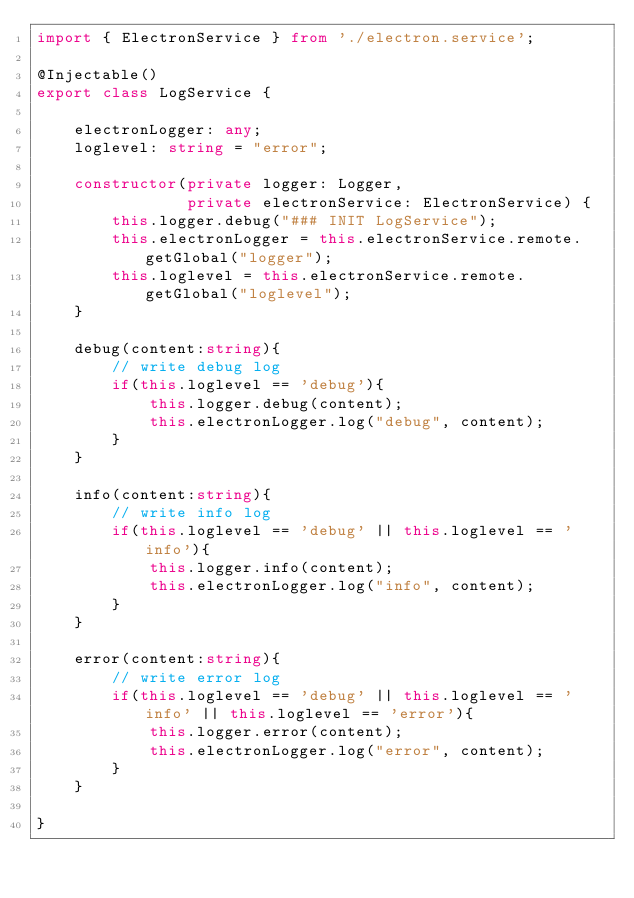Convert code to text. <code><loc_0><loc_0><loc_500><loc_500><_TypeScript_>import { ElectronService } from './electron.service';

@Injectable()
export class LogService {

    electronLogger: any;
    loglevel: string = "error";

    constructor(private logger: Logger,
                private electronService: ElectronService) {
        this.logger.debug("### INIT LogService");
        this.electronLogger = this.electronService.remote.getGlobal("logger");
        this.loglevel = this.electronService.remote.getGlobal("loglevel");
    }

    debug(content:string){
        // write debug log
        if(this.loglevel == 'debug'){
            this.logger.debug(content);
            this.electronLogger.log("debug", content);
        }
    }

    info(content:string){
        // write info log
        if(this.loglevel == 'debug' || this.loglevel == 'info'){
            this.logger.info(content);
            this.electronLogger.log("info", content);
        }
    }

    error(content:string){
        // write error log
        if(this.loglevel == 'debug' || this.loglevel == 'info' || this.loglevel == 'error'){
            this.logger.error(content);
            this.electronLogger.log("error", content);
        }
    }

}</code> 